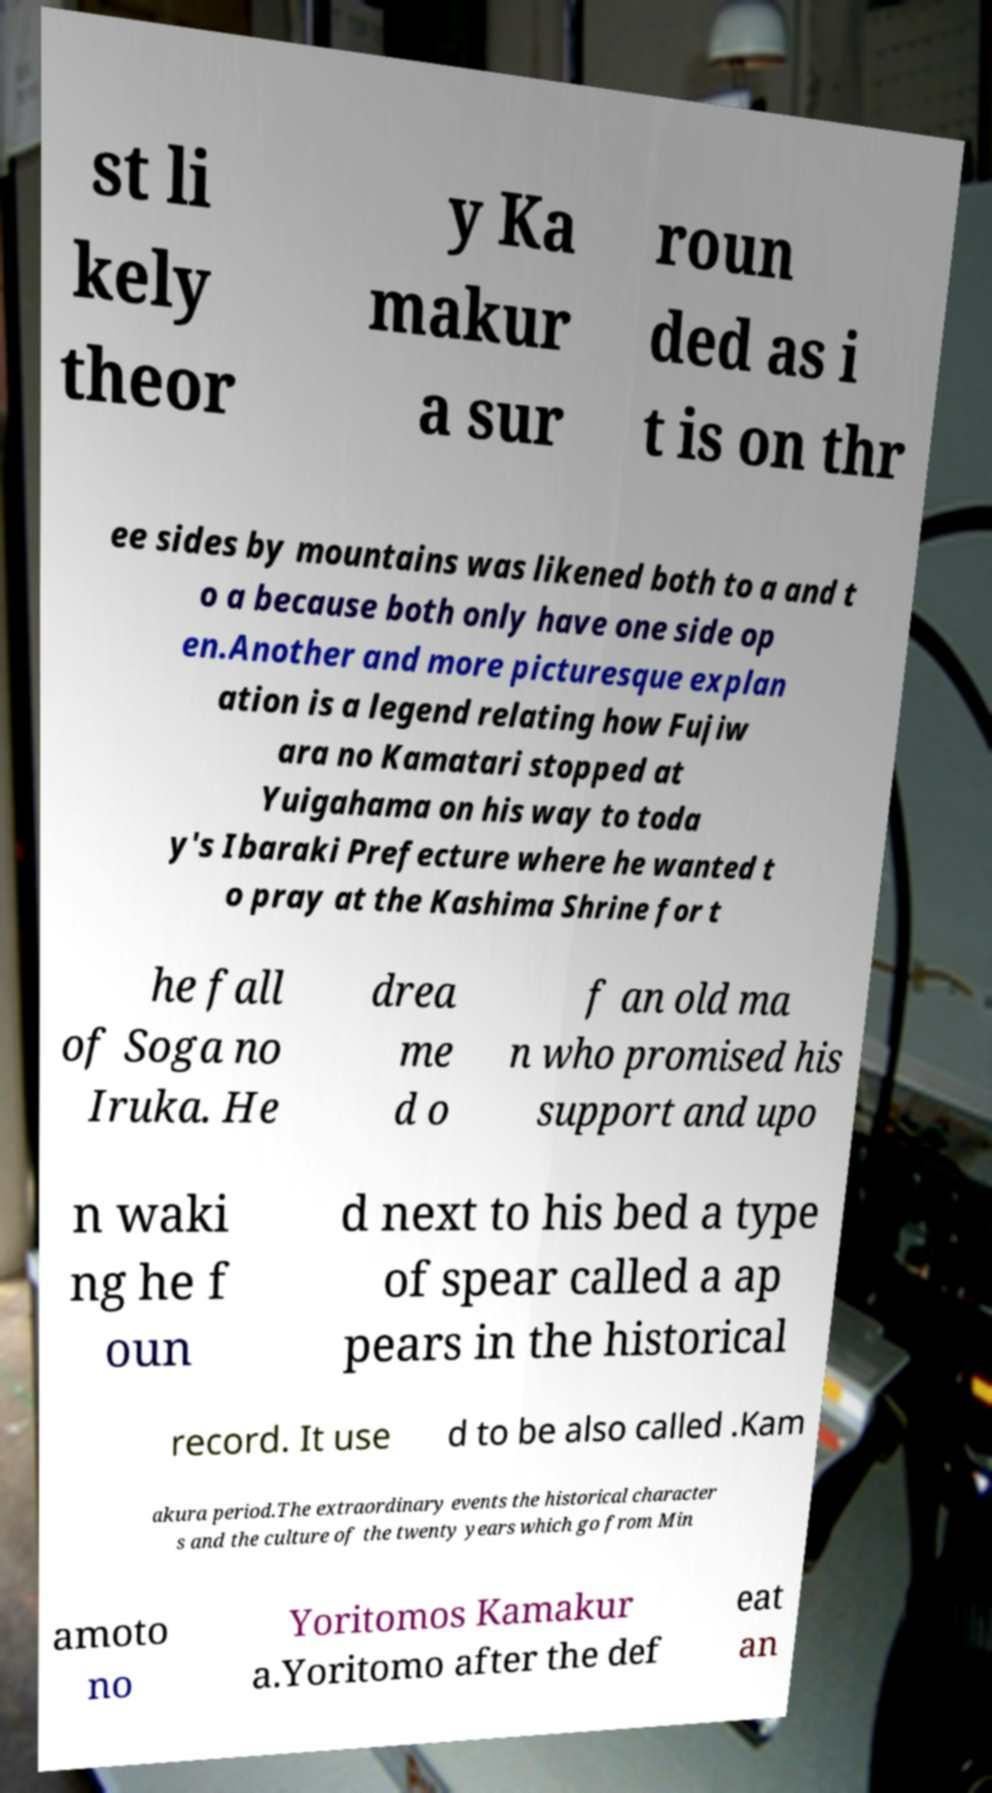Could you assist in decoding the text presented in this image and type it out clearly? st li kely theor y Ka makur a sur roun ded as i t is on thr ee sides by mountains was likened both to a and t o a because both only have one side op en.Another and more picturesque explan ation is a legend relating how Fujiw ara no Kamatari stopped at Yuigahama on his way to toda y's Ibaraki Prefecture where he wanted t o pray at the Kashima Shrine for t he fall of Soga no Iruka. He drea me d o f an old ma n who promised his support and upo n waki ng he f oun d next to his bed a type of spear called a ap pears in the historical record. It use d to be also called .Kam akura period.The extraordinary events the historical character s and the culture of the twenty years which go from Min amoto no Yoritomos Kamakur a.Yoritomo after the def eat an 